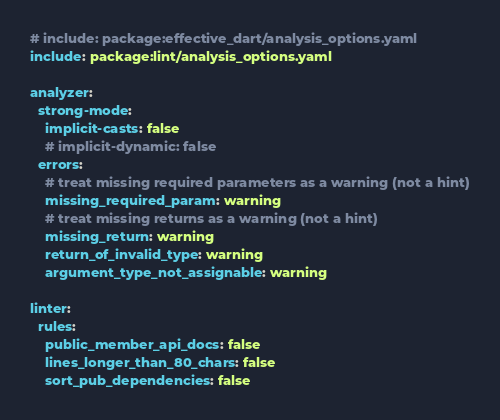Convert code to text. <code><loc_0><loc_0><loc_500><loc_500><_YAML_># include: package:effective_dart/analysis_options.yaml
include: package:lint/analysis_options.yaml

analyzer:
  strong-mode:
    implicit-casts: false
    # implicit-dynamic: false
  errors:
    # treat missing required parameters as a warning (not a hint)
    missing_required_param: warning
    # treat missing returns as a warning (not a hint)
    missing_return: warning
    return_of_invalid_type: warning
    argument_type_not_assignable: warning

linter:
  rules:
    public_member_api_docs: false
    lines_longer_than_80_chars: false
    sort_pub_dependencies: false</code> 